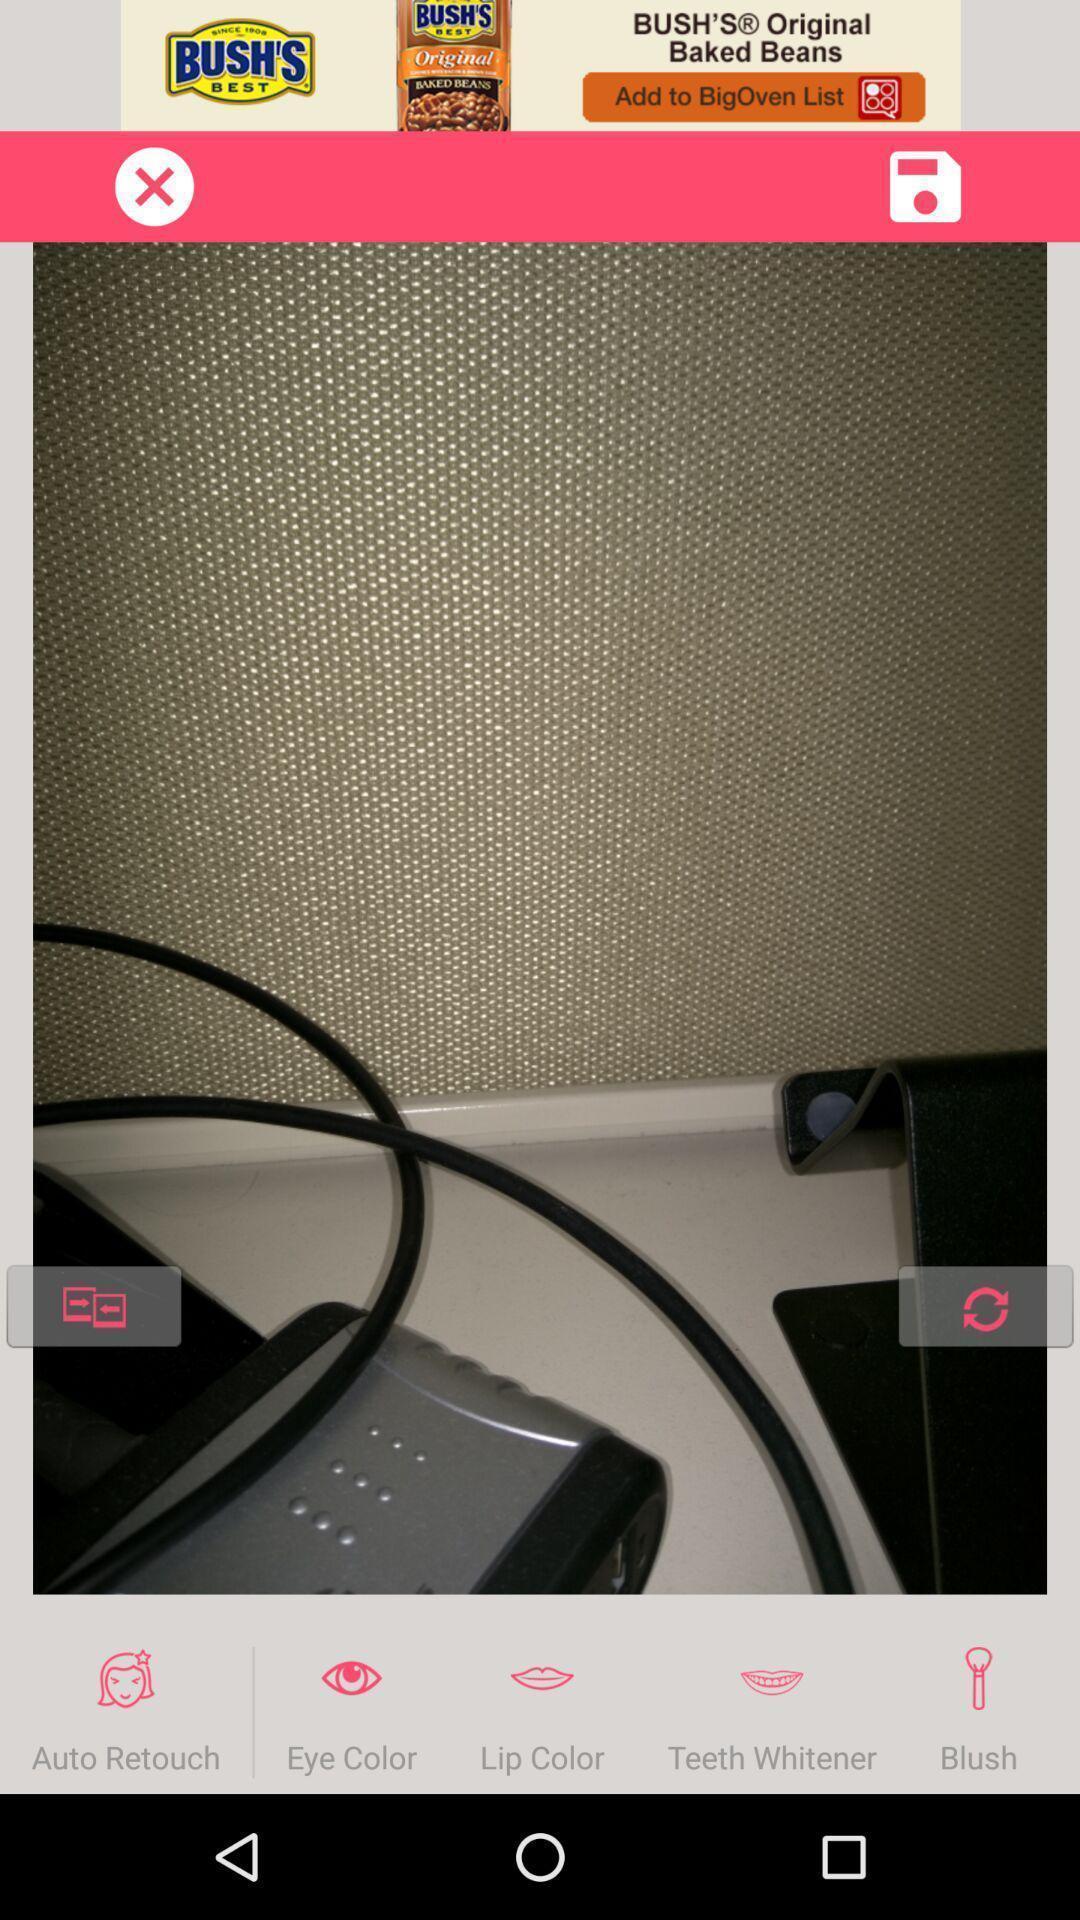What details can you identify in this image? Page displaying the interface of an image editing app. 